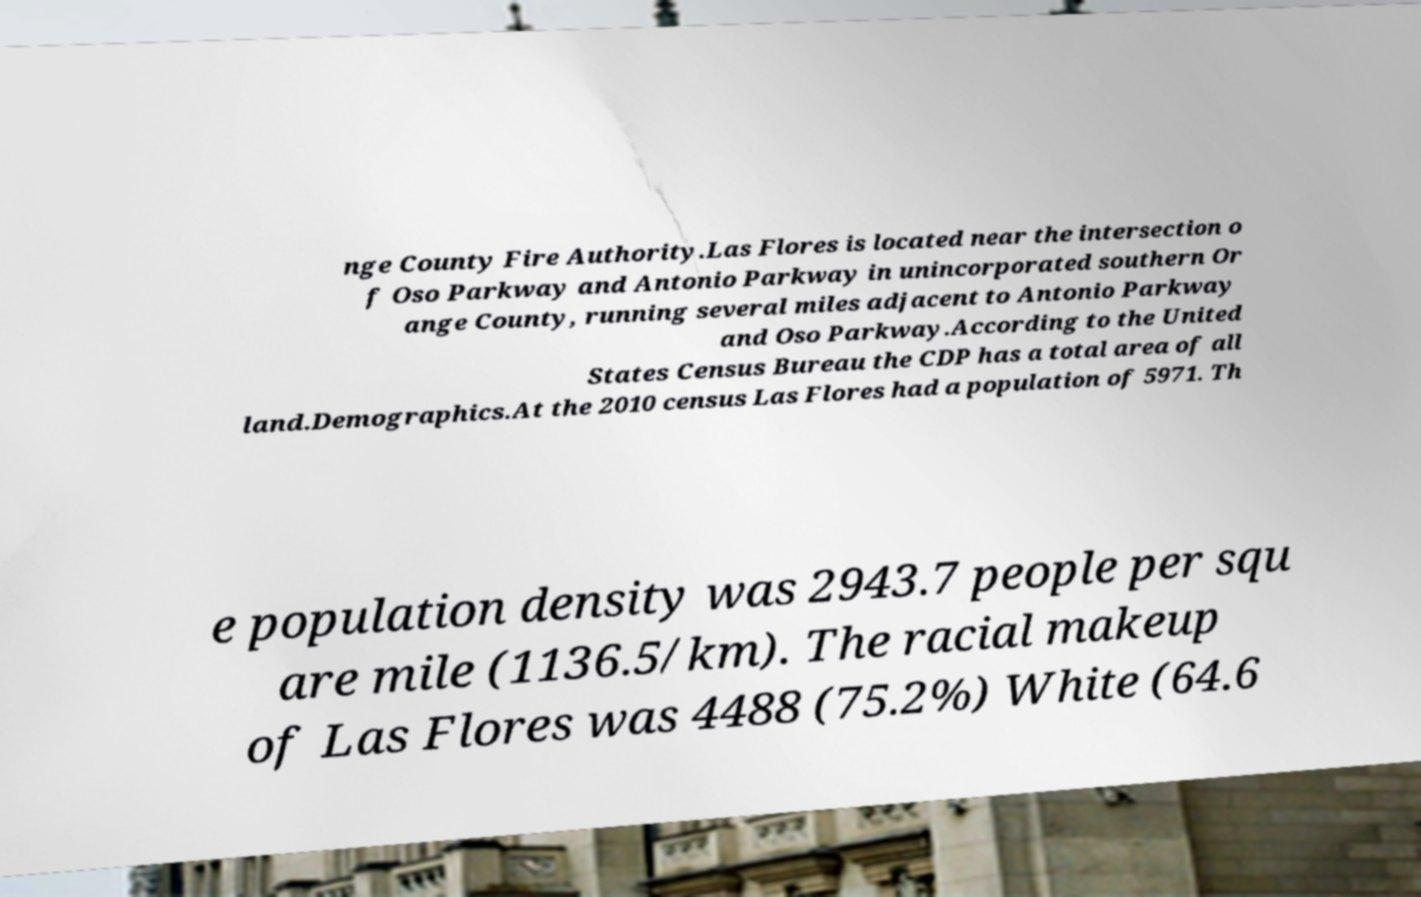Can you accurately transcribe the text from the provided image for me? nge County Fire Authority.Las Flores is located near the intersection o f Oso Parkway and Antonio Parkway in unincorporated southern Or ange County, running several miles adjacent to Antonio Parkway and Oso Parkway.According to the United States Census Bureau the CDP has a total area of all land.Demographics.At the 2010 census Las Flores had a population of 5971. Th e population density was 2943.7 people per squ are mile (1136.5/km). The racial makeup of Las Flores was 4488 (75.2%) White (64.6 